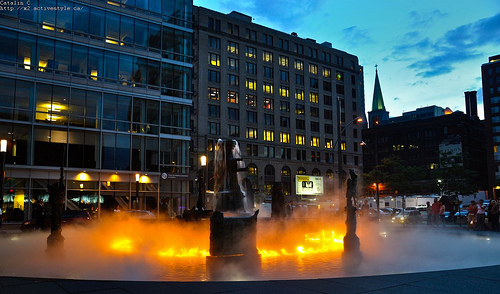<image>
Is the fire in the water? Yes. The fire is contained within or inside the water, showing a containment relationship. 